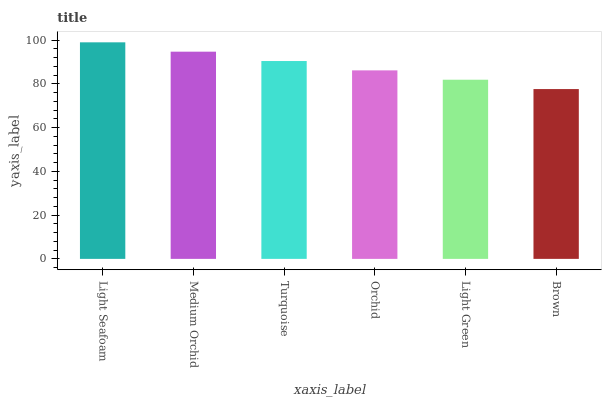Is Brown the minimum?
Answer yes or no. Yes. Is Light Seafoam the maximum?
Answer yes or no. Yes. Is Medium Orchid the minimum?
Answer yes or no. No. Is Medium Orchid the maximum?
Answer yes or no. No. Is Light Seafoam greater than Medium Orchid?
Answer yes or no. Yes. Is Medium Orchid less than Light Seafoam?
Answer yes or no. Yes. Is Medium Orchid greater than Light Seafoam?
Answer yes or no. No. Is Light Seafoam less than Medium Orchid?
Answer yes or no. No. Is Turquoise the high median?
Answer yes or no. Yes. Is Orchid the low median?
Answer yes or no. Yes. Is Medium Orchid the high median?
Answer yes or no. No. Is Light Seafoam the low median?
Answer yes or no. No. 